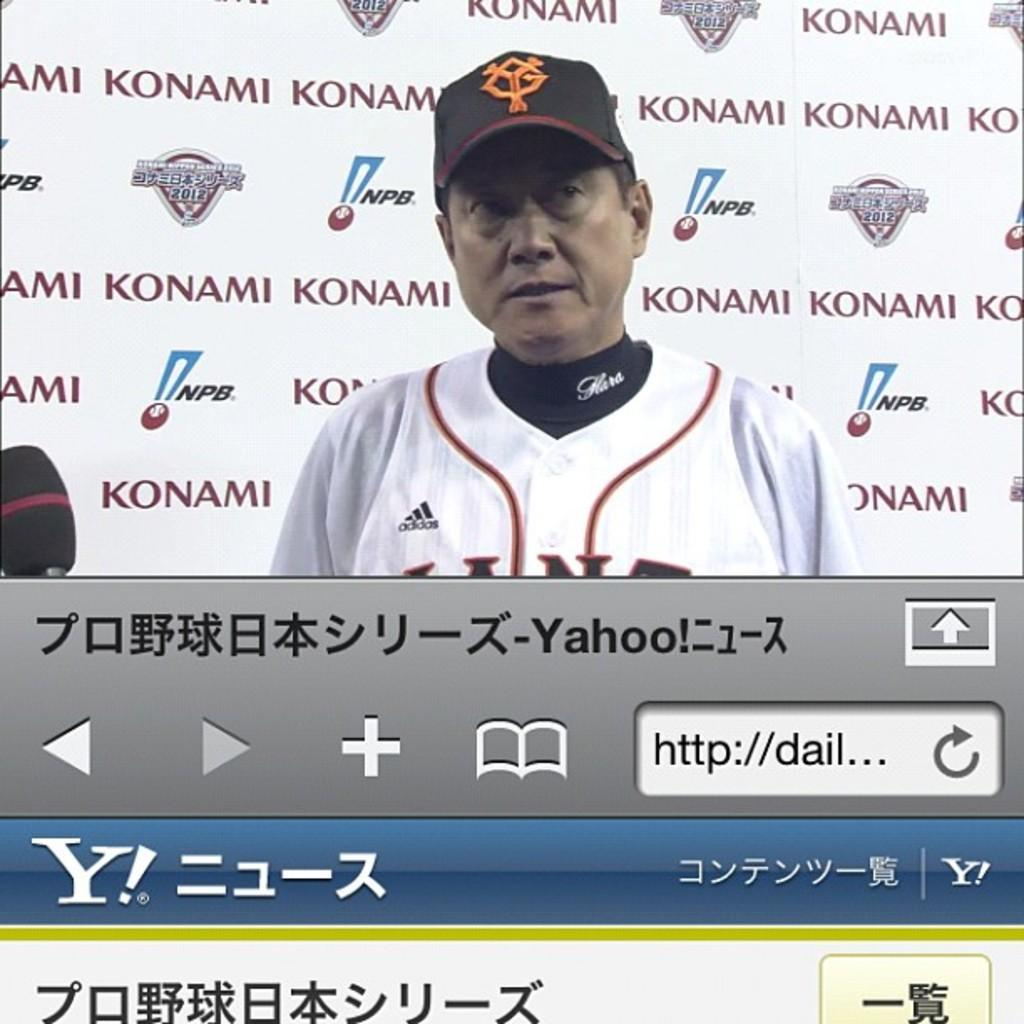Provide a one-sentence caption for the provided image. A Japanese baseball player is shown on Yahoo's website. 